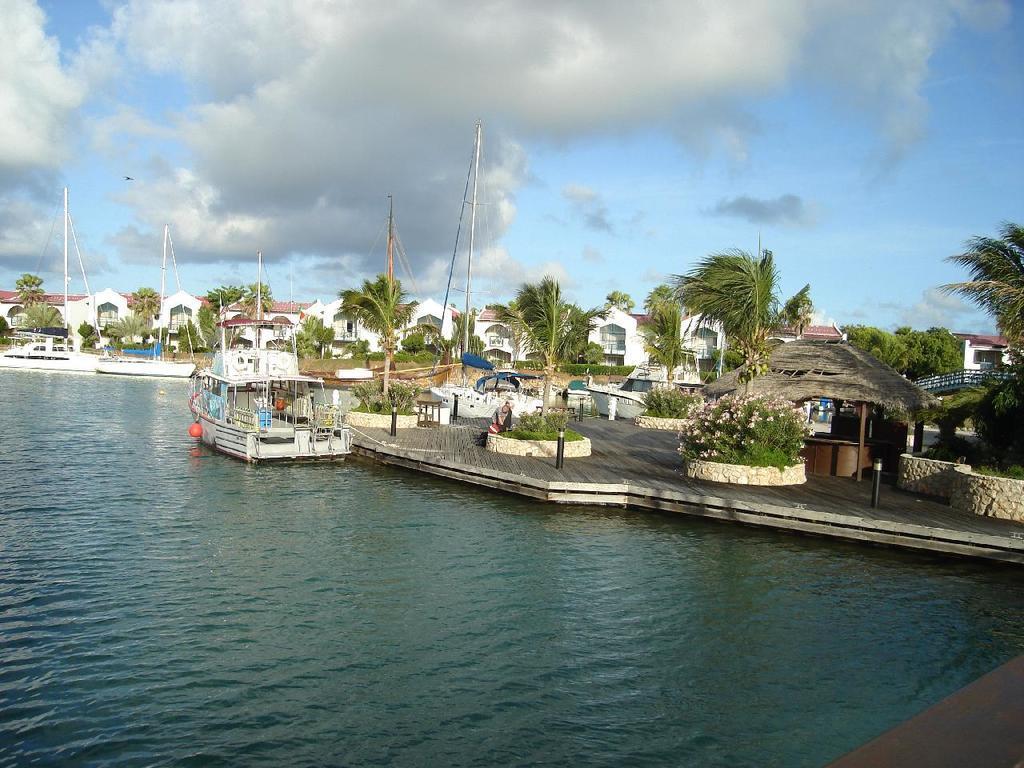Can you describe this image briefly? In this image, I can see the boats on the water. This looks like a wooden platform. I can see a tree with flowers. These are the houses and the trees. This looks like a hut. I can see a person sitting. These are the clouds in the sky. 